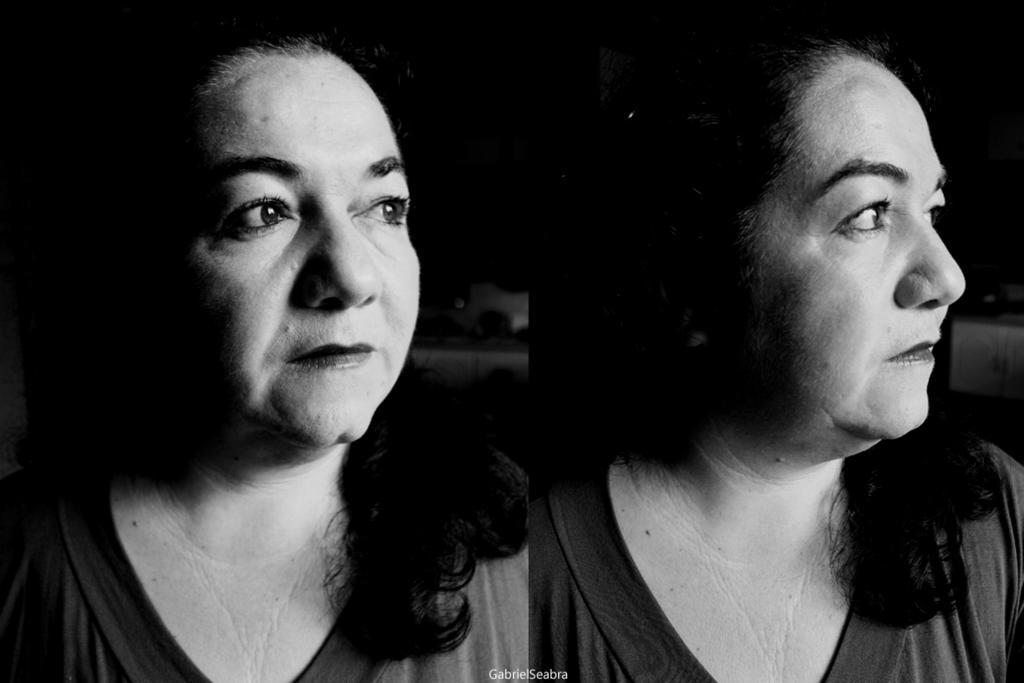Could you give a brief overview of what you see in this image? In this picture I can see a woman. This image is a collage picture. This picture is black and white in color. 